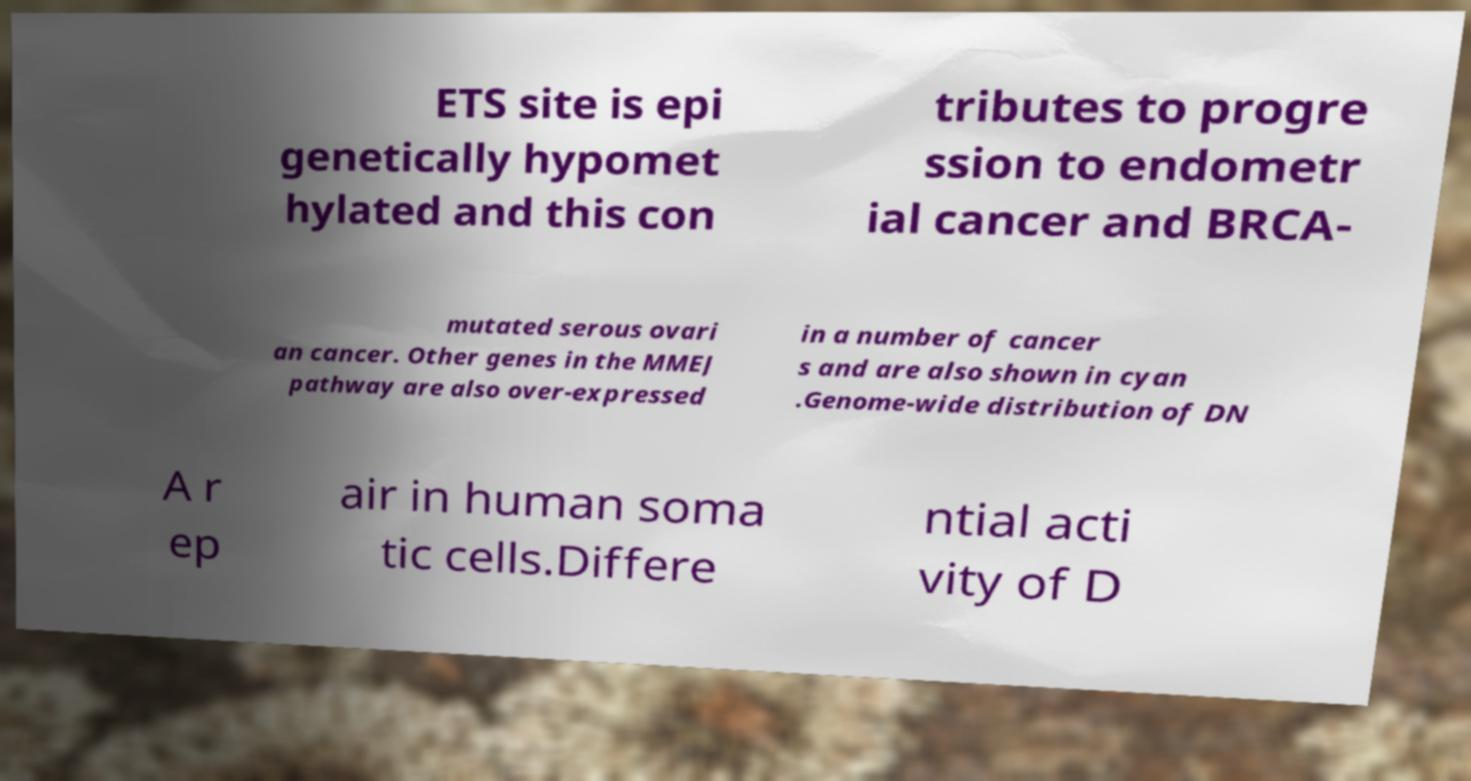Could you assist in decoding the text presented in this image and type it out clearly? ETS site is epi genetically hypomet hylated and this con tributes to progre ssion to endometr ial cancer and BRCA- mutated serous ovari an cancer. Other genes in the MMEJ pathway are also over-expressed in a number of cancer s and are also shown in cyan .Genome-wide distribution of DN A r ep air in human soma tic cells.Differe ntial acti vity of D 